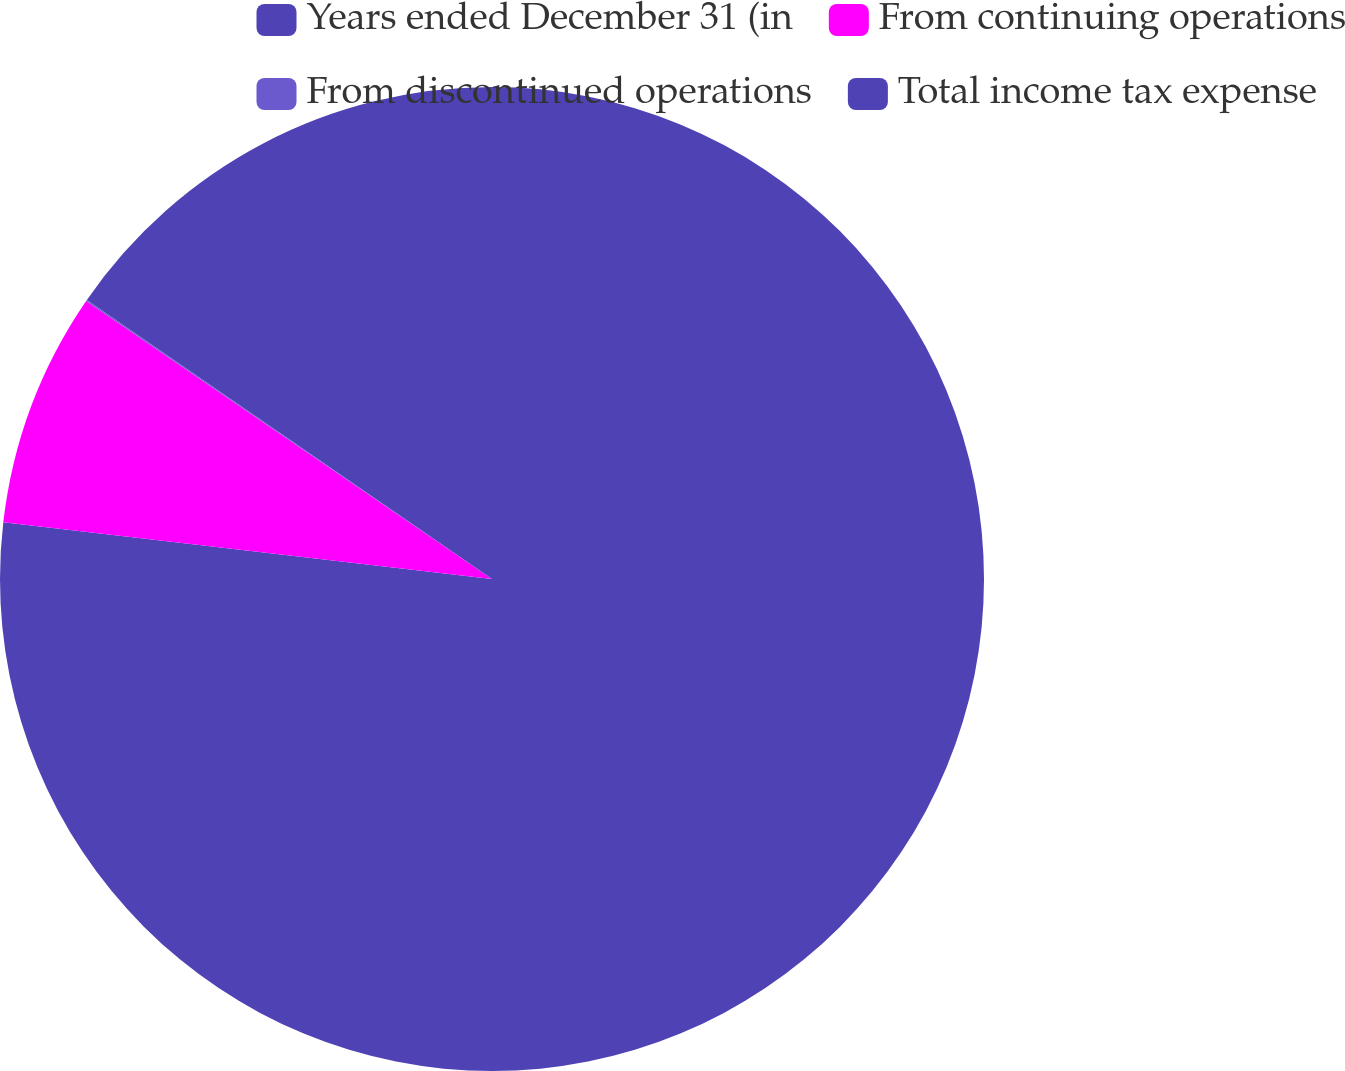Convert chart to OTSL. <chart><loc_0><loc_0><loc_500><loc_500><pie_chart><fcel>Years ended December 31 (in<fcel>From continuing operations<fcel>From discontinued operations<fcel>Total income tax expense<nl><fcel>76.84%<fcel>7.72%<fcel>0.04%<fcel>15.4%<nl></chart> 